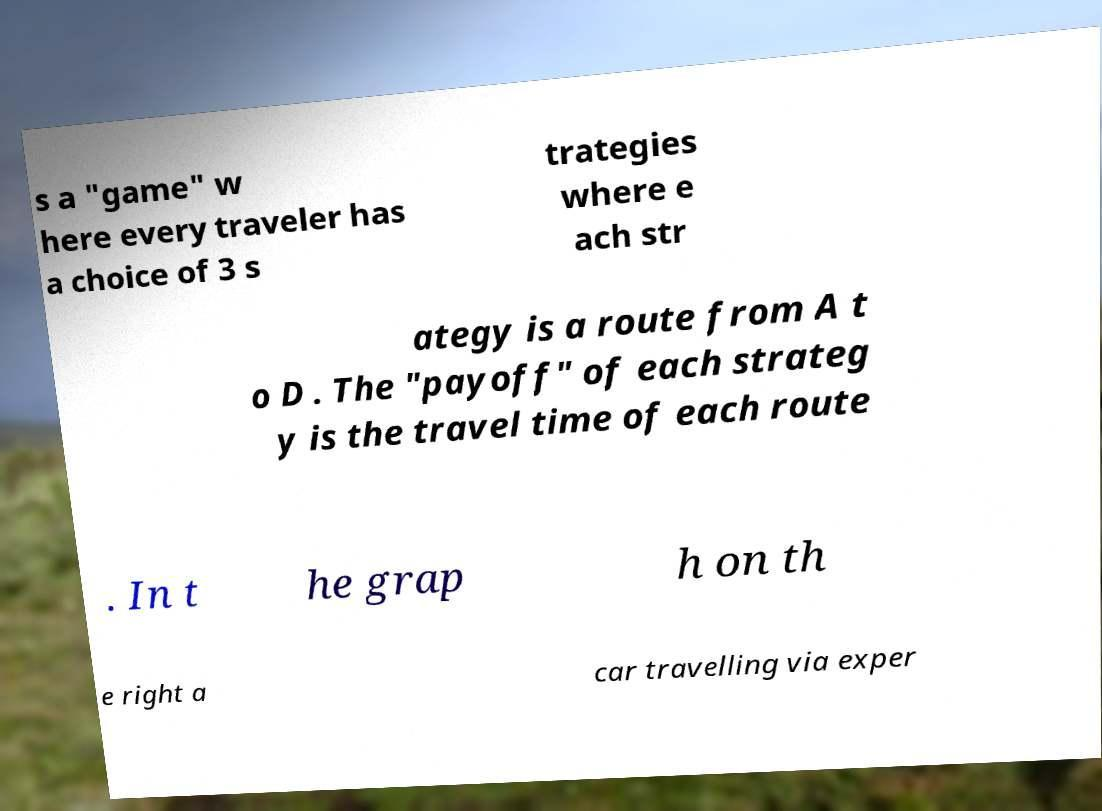I need the written content from this picture converted into text. Can you do that? s a "game" w here every traveler has a choice of 3 s trategies where e ach str ategy is a route from A t o D . The "payoff" of each strateg y is the travel time of each route . In t he grap h on th e right a car travelling via exper 